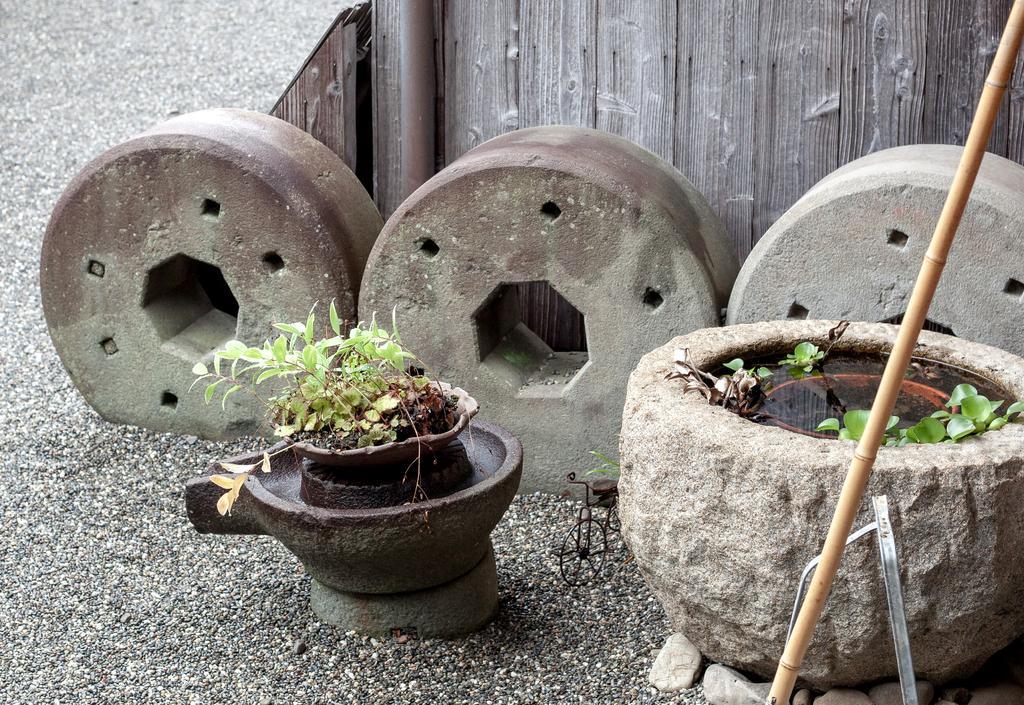Please provide a concise description of this image. In the center of the image there are plants. In the background of the image there are some circular objects. At the bottom of the image there are stones. To the right side of the image there is a stick. 